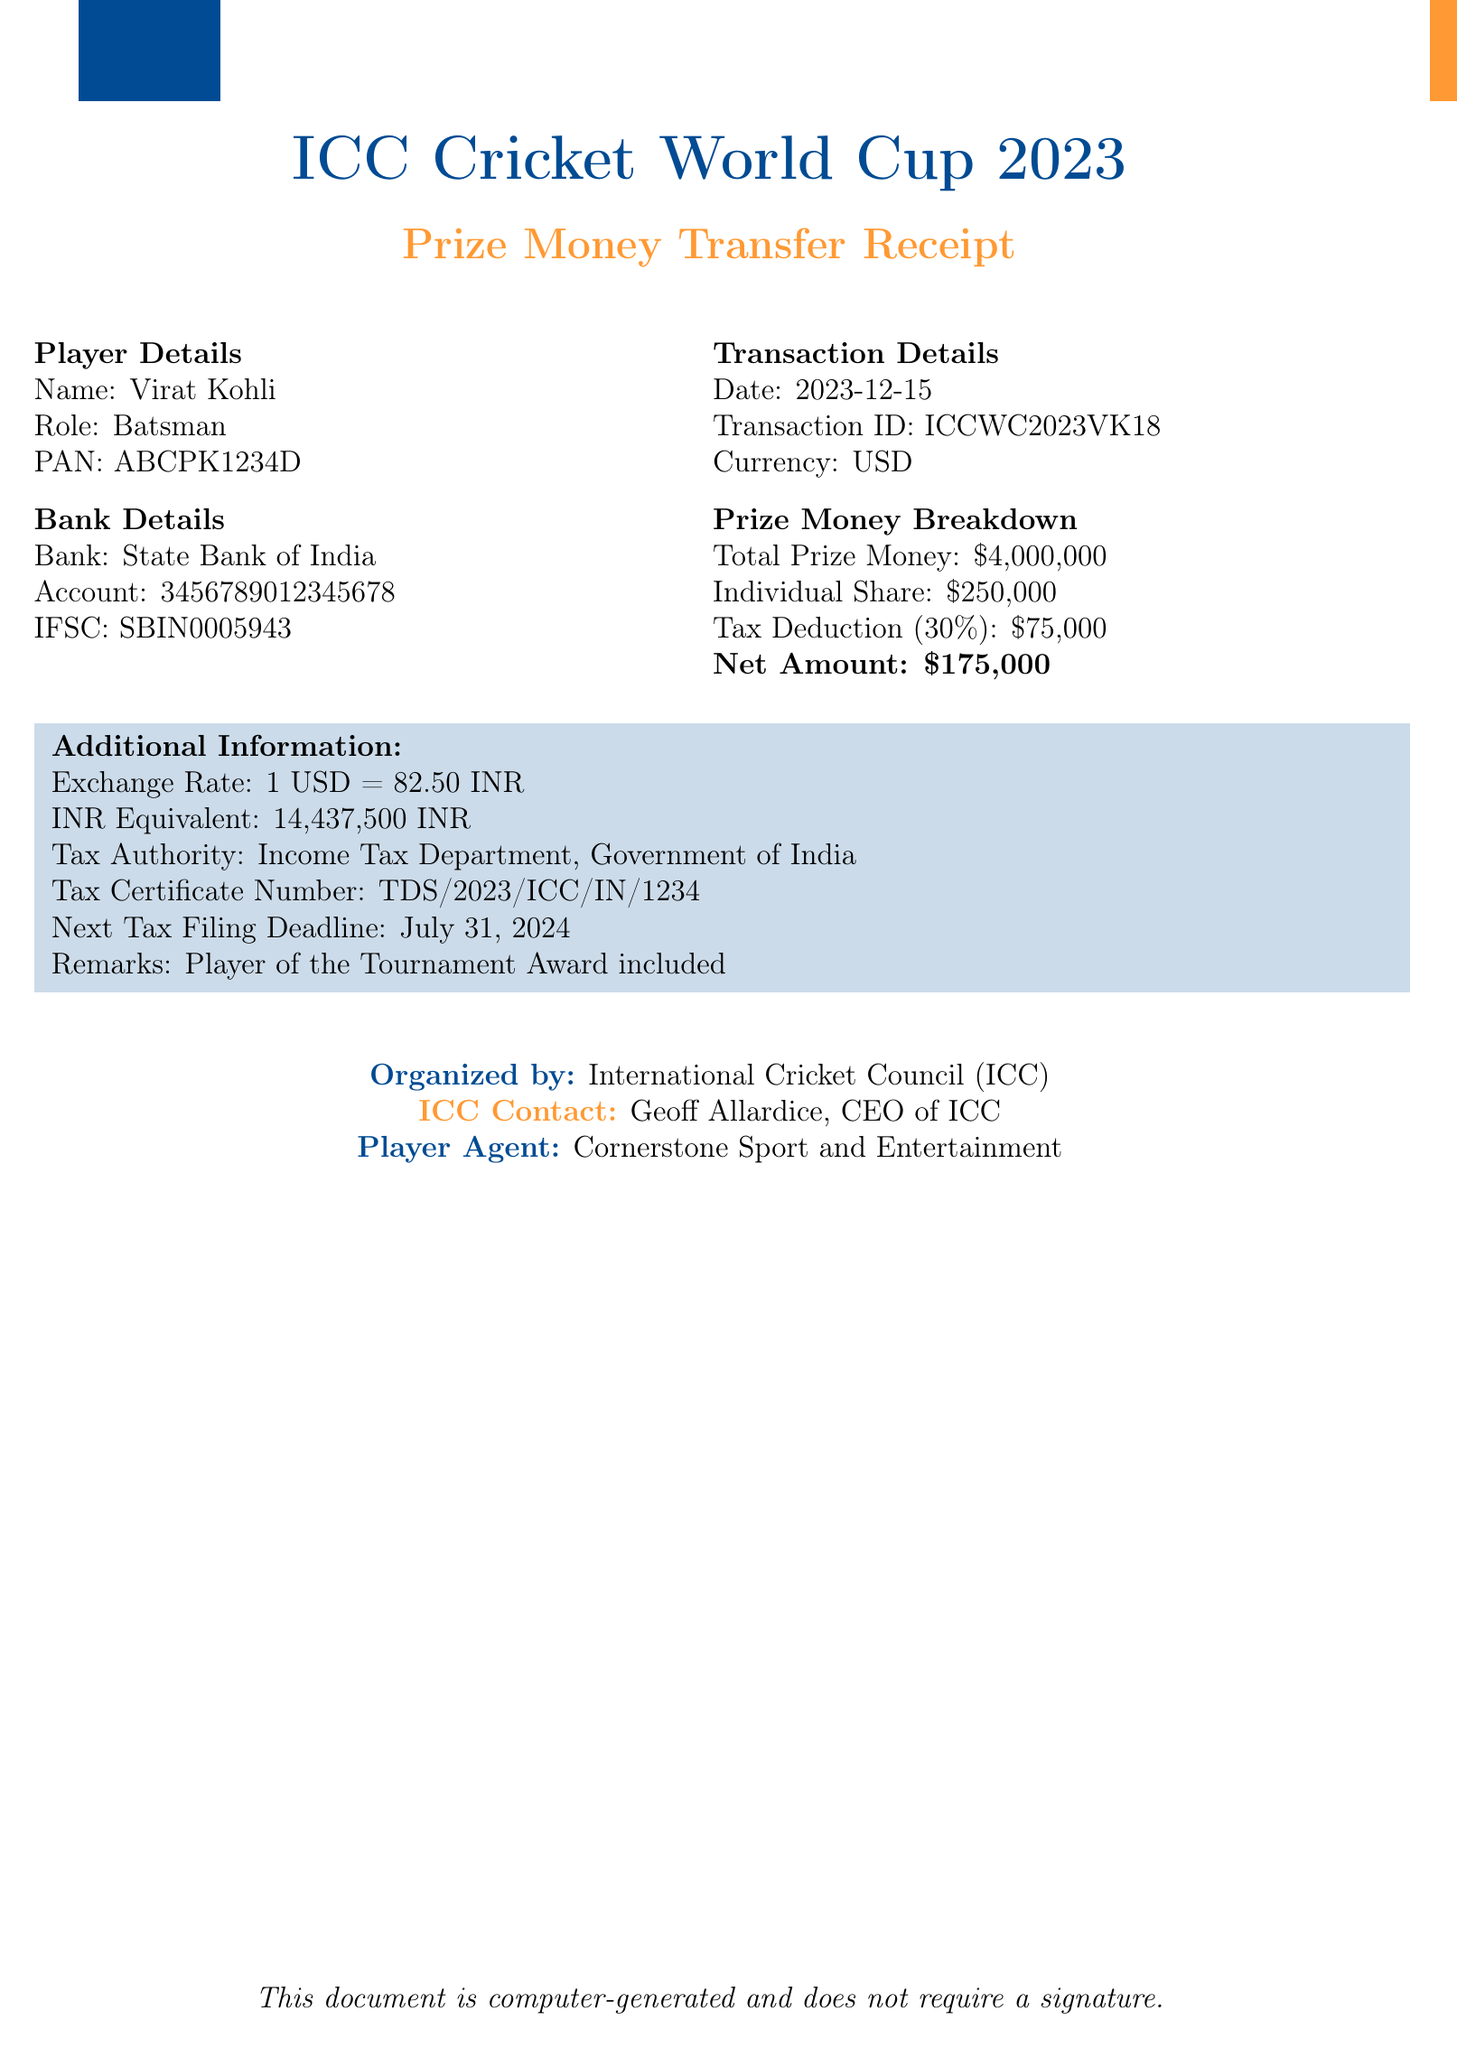What is the championship name? The championship name is stated at the beginning of the document as the title.
Answer: ICC Cricket World Cup 2023 What is the player’s individual share of the prize money? The individual share is directly mentioned in the prize money breakdown section of the document.
Answer: $250,000 What is the tax deduction rate applied? The tax deduction rate is specified in the prize money breakdown section of the document.
Answer: 30% How much was deducted for taxes? The tax deduction amount is clearly specified in the document.
Answer: $75,000 What is the net amount transferred to the player? The net amount is highlighted in the prize money breakdown and is a key figure in the transaction.
Answer: $175,000 What is the date of the transaction? The transaction date is explicitly mentioned in the transaction details section.
Answer: 2023-12-15 How much is the INR equivalent of the prize money? The INR equivalent is provided in the additional information section of the document.
Answer: 14,437,500 INR Who is the contact person at the ICC? The contact person is noted in the document under the organized by section.
Answer: Geoff Allardice, CEO of ICC What is the next tax filing deadline? The next tax filing deadline is mentioned as part of the additional information.
Answer: July 31, 2024 